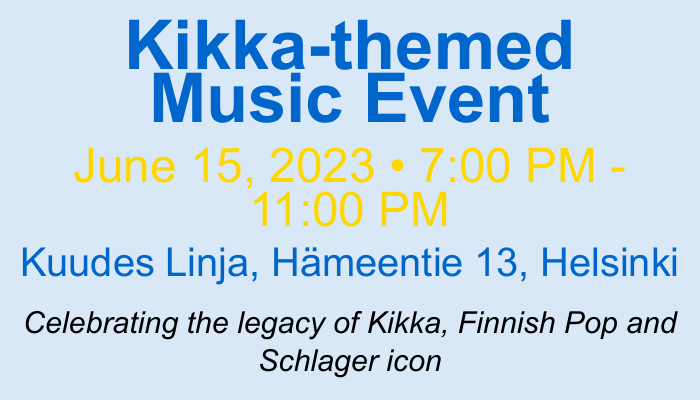What is the date of the event? The date of the event is clearly stated in the document as June 15, 2023.
Answer: June 15, 2023 What is the time duration of the event? The time during which the event will take place is specified as 7:00 PM - 11:00 PM.
Answer: 7:00 PM - 11:00 PM Where is the event located? The location of the event is provided in the document as Kuudes Linja, Hämeentie 13, Helsinki.
Answer: Kuudes Linja, Hämeentie 13, Helsinki What type of music does the event celebrate? The document mentions that the event celebrates Kikka's impact on Finnish Pop and Schlager music.
Answer: Finnish Pop and Schlager What is a brief description of the event? The document includes a description stating that it is an unforgettable evening honoring Kikka's impact on Finnish music.
Answer: An unforgettable evening honoring Kikka's impact on Finnish music What contact information is provided? The document provides a contact email and phone number for inquiries: info@kikkafans.fi and +358 50 123 4567.
Answer: info@kikkafans.fi • +358 50 123 4567 Why is Kikka significant to Finnish music? The document describes Kikka as a Finnish Pop and Schlager icon, indicating her significance.
Answer: Finnish Pop and Schlager icon What design elements are used on the card? The card uses colors such as kikkaBlue and kikkaGold along with different font sizes to emphasize details.
Answer: kikkaBlue and kikkaGold 